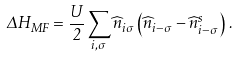Convert formula to latex. <formula><loc_0><loc_0><loc_500><loc_500>\Delta H _ { M F } = \frac { U } { 2 } \sum _ { i , \sigma } \widehat { n } _ { i \sigma } \left ( \widehat { n } _ { i - \sigma } - \widehat { n } _ { i - \sigma } ^ { s } \right ) \, .</formula> 